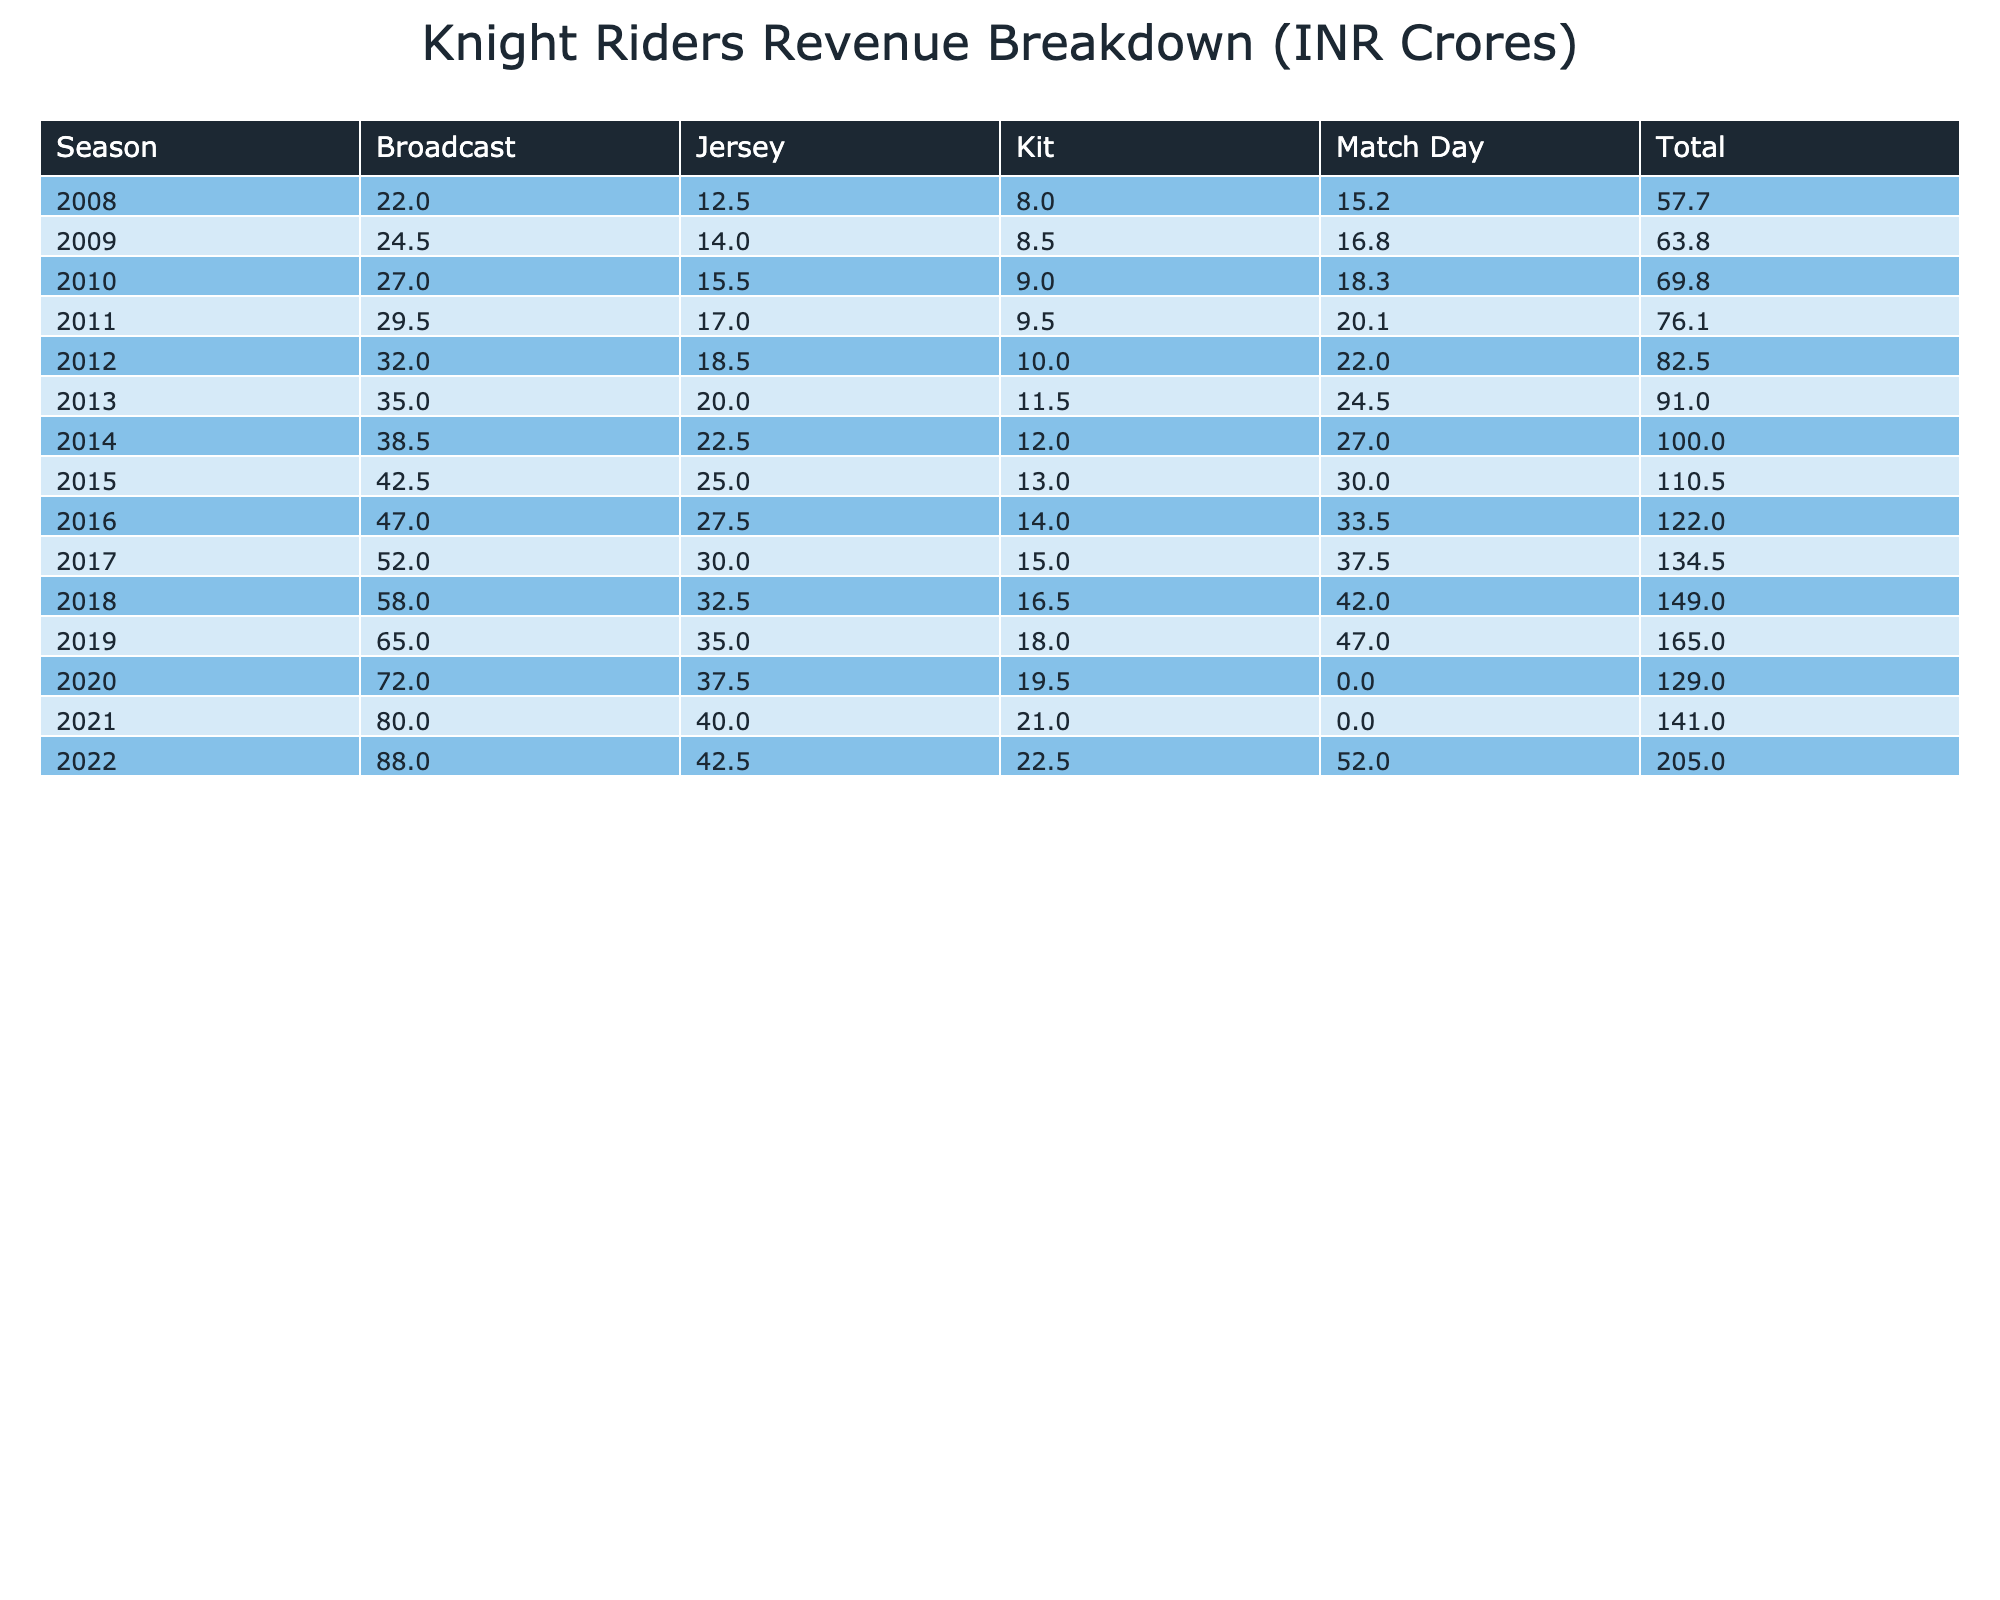What was the total revenue for Knight Riders in the 2013 season? For the 2013 season, we need to sum the revenues from all types: Jersey (20.0), Kit (11.5), Match Day (24.5), and Broadcast (35.0). Adding these gives us 20.0 + 11.5 + 24.5 + 35.0 = 91.0 crore.
Answer: 91.0 Which season had the highest revenue from TV Rights? By inspecting the TV Rights revenue across each season, the highest value is found in 2022 with 88.0 crore.
Answer: 2022 Did the Knight Riders receive more revenue from Ticket Sales or Jersey sponsorship in the 2020 season? For 2020, Ticket Sales brought in 0, while Jersey sponsorship contributed 37.5 crore. Thus, the revenue from Jersey sponsorship is higher than Ticket Sales.
Answer: Yes What is the average revenue from Kit sponsorship over all seasons? Adding up the Kit revenues: 8.0 + 8.5 + 9.0 + 9.5 + 10.0 + 11.5 + 12.0 + 13.0 + 14.0 + 15.0 + 16.5 + 18.0 + 19.5 + 21.0 + 22.5 gives 220.5 crores. There are 15 seasons contributing to this, so the average is 220.5 / 15 = 14.7.
Answer: 14.7 In which year did the cumulative revenue from Match Day tickets across all previous seasons exceed 100 crore for the first time? We must keep a running total of Match Day revenues: for each season: 15.2 (2008) + 16.8 (2009) + 18.3 (2010) + 20.1 (2011) + 22.0 (2012) + 24.5 (2013) + 27.0 (2014) + 30.0 (2015) + 33.5 (2016) + 37.5 (2017) + 42.0 (2018) + 47.0 (2019) + 0 (2020; season skipped due to COVID). The cumulative total surpasses 100 crore in 2015 after summing up to 109.3 crores up to that season.
Answer: 2015 